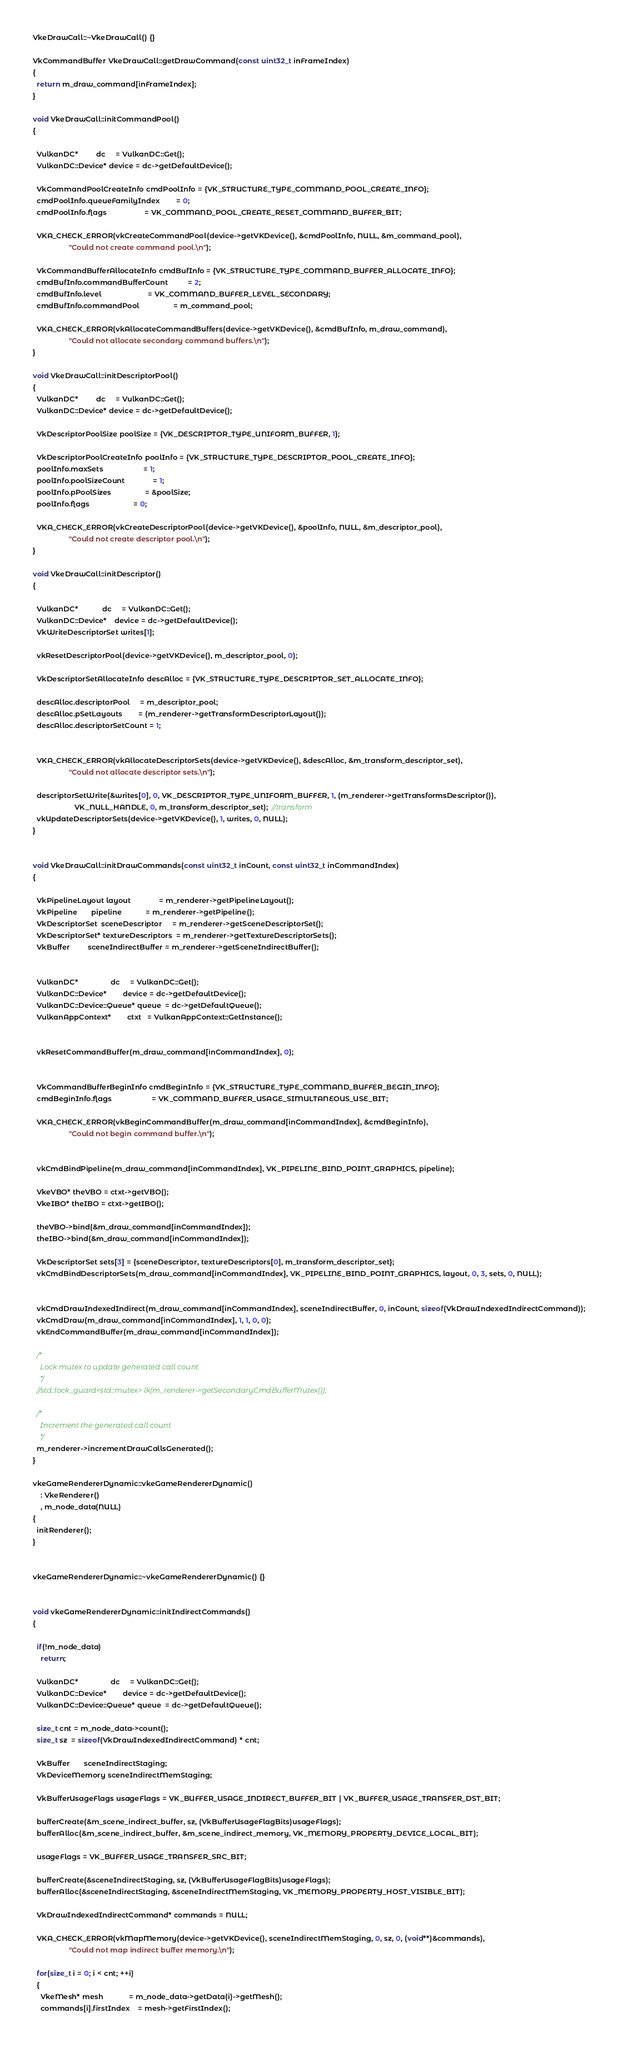Convert code to text. <code><loc_0><loc_0><loc_500><loc_500><_C++_>VkeDrawCall::~VkeDrawCall() {}

VkCommandBuffer VkeDrawCall::getDrawCommand(const uint32_t inFrameIndex)
{
  return m_draw_command[inFrameIndex];
}

void VkeDrawCall::initCommandPool()
{

  VulkanDC*         dc     = VulkanDC::Get();
  VulkanDC::Device* device = dc->getDefaultDevice();

  VkCommandPoolCreateInfo cmdPoolInfo = {VK_STRUCTURE_TYPE_COMMAND_POOL_CREATE_INFO};
  cmdPoolInfo.queueFamilyIndex        = 0;
  cmdPoolInfo.flags                   = VK_COMMAND_POOL_CREATE_RESET_COMMAND_BUFFER_BIT;

  VKA_CHECK_ERROR(vkCreateCommandPool(device->getVKDevice(), &cmdPoolInfo, NULL, &m_command_pool),
                  "Could not create command pool.\n");

  VkCommandBufferAllocateInfo cmdBufInfo = {VK_STRUCTURE_TYPE_COMMAND_BUFFER_ALLOCATE_INFO};
  cmdBufInfo.commandBufferCount          = 2;
  cmdBufInfo.level                       = VK_COMMAND_BUFFER_LEVEL_SECONDARY;
  cmdBufInfo.commandPool                 = m_command_pool;

  VKA_CHECK_ERROR(vkAllocateCommandBuffers(device->getVKDevice(), &cmdBufInfo, m_draw_command),
                  "Could not allocate secondary command buffers.\n");
}

void VkeDrawCall::initDescriptorPool()
{
  VulkanDC*         dc     = VulkanDC::Get();
  VulkanDC::Device* device = dc->getDefaultDevice();

  VkDescriptorPoolSize poolSize = {VK_DESCRIPTOR_TYPE_UNIFORM_BUFFER, 1};

  VkDescriptorPoolCreateInfo poolInfo = {VK_STRUCTURE_TYPE_DESCRIPTOR_POOL_CREATE_INFO};
  poolInfo.maxSets                    = 1;
  poolInfo.poolSizeCount              = 1;
  poolInfo.pPoolSizes                 = &poolSize;
  poolInfo.flags                      = 0;

  VKA_CHECK_ERROR(vkCreateDescriptorPool(device->getVKDevice(), &poolInfo, NULL, &m_descriptor_pool),
                  "Could not create descriptor pool.\n");
}

void VkeDrawCall::initDescriptor()
{

  VulkanDC*            dc     = VulkanDC::Get();
  VulkanDC::Device*    device = dc->getDefaultDevice();
  VkWriteDescriptorSet writes[1];

  vkResetDescriptorPool(device->getVKDevice(), m_descriptor_pool, 0);

  VkDescriptorSetAllocateInfo descAlloc = {VK_STRUCTURE_TYPE_DESCRIPTOR_SET_ALLOCATE_INFO};

  descAlloc.descriptorPool     = m_descriptor_pool;
  descAlloc.pSetLayouts        = (m_renderer->getTransformDescriptorLayout());
  descAlloc.descriptorSetCount = 1;


  VKA_CHECK_ERROR(vkAllocateDescriptorSets(device->getVKDevice(), &descAlloc, &m_transform_descriptor_set),
                  "Could not allocate descriptor sets.\n");

  descriptorSetWrite(&writes[0], 0, VK_DESCRIPTOR_TYPE_UNIFORM_BUFFER, 1, (m_renderer->getTransformsDescriptor()),
                     VK_NULL_HANDLE, 0, m_transform_descriptor_set);  //transform
  vkUpdateDescriptorSets(device->getVKDevice(), 1, writes, 0, NULL);
}


void VkeDrawCall::initDrawCommands(const uint32_t inCount, const uint32_t inCommandIndex)
{

  VkPipelineLayout layout              = m_renderer->getPipelineLayout();
  VkPipeline       pipeline            = m_renderer->getPipeline();
  VkDescriptorSet  sceneDescriptor     = m_renderer->getSceneDescriptorSet();
  VkDescriptorSet* textureDescriptors  = m_renderer->getTextureDescriptorSets();
  VkBuffer         sceneIndirectBuffer = m_renderer->getSceneIndirectBuffer();


  VulkanDC*                dc     = VulkanDC::Get();
  VulkanDC::Device*        device = dc->getDefaultDevice();
  VulkanDC::Device::Queue* queue  = dc->getDefaultQueue();
  VulkanAppContext*        ctxt   = VulkanAppContext::GetInstance();


  vkResetCommandBuffer(m_draw_command[inCommandIndex], 0);


  VkCommandBufferBeginInfo cmdBeginInfo = {VK_STRUCTURE_TYPE_COMMAND_BUFFER_BEGIN_INFO};
  cmdBeginInfo.flags                    = VK_COMMAND_BUFFER_USAGE_SIMULTANEOUS_USE_BIT;

  VKA_CHECK_ERROR(vkBeginCommandBuffer(m_draw_command[inCommandIndex], &cmdBeginInfo),
                  "Could not begin command buffer.\n");


  vkCmdBindPipeline(m_draw_command[inCommandIndex], VK_PIPELINE_BIND_POINT_GRAPHICS, pipeline);

  VkeVBO* theVBO = ctxt->getVBO();
  VkeIBO* theIBO = ctxt->getIBO();

  theVBO->bind(&m_draw_command[inCommandIndex]);
  theIBO->bind(&m_draw_command[inCommandIndex]);

  VkDescriptorSet sets[3] = {sceneDescriptor, textureDescriptors[0], m_transform_descriptor_set};
  vkCmdBindDescriptorSets(m_draw_command[inCommandIndex], VK_PIPELINE_BIND_POINT_GRAPHICS, layout, 0, 3, sets, 0, NULL);


  vkCmdDrawIndexedIndirect(m_draw_command[inCommandIndex], sceneIndirectBuffer, 0, inCount, sizeof(VkDrawIndexedIndirectCommand));
  vkCmdDraw(m_draw_command[inCommandIndex], 1, 1, 0, 0);
  vkEndCommandBuffer(m_draw_command[inCommandIndex]);

  /*
	Lock mutex to update generated call count.
	*/
  //std::lock_guard<std::mutex> lk(m_renderer->getSecondaryCmdBufferMutex());

  /*
	Increment the generated call count
	*/
  m_renderer->incrementDrawCallsGenerated();
}

vkeGameRendererDynamic::vkeGameRendererDynamic()
    : VkeRenderer()
    , m_node_data(NULL)
{
  initRenderer();
}


vkeGameRendererDynamic::~vkeGameRendererDynamic() {}


void vkeGameRendererDynamic::initIndirectCommands()
{

  if(!m_node_data)
    return;

  VulkanDC*                dc     = VulkanDC::Get();
  VulkanDC::Device*        device = dc->getDefaultDevice();
  VulkanDC::Device::Queue* queue  = dc->getDefaultQueue();

  size_t cnt = m_node_data->count();
  size_t sz  = sizeof(VkDrawIndexedIndirectCommand) * cnt;

  VkBuffer       sceneIndirectStaging;
  VkDeviceMemory sceneIndirectMemStaging;

  VkBufferUsageFlags usageFlags = VK_BUFFER_USAGE_INDIRECT_BUFFER_BIT | VK_BUFFER_USAGE_TRANSFER_DST_BIT;

  bufferCreate(&m_scene_indirect_buffer, sz, (VkBufferUsageFlagBits)usageFlags);
  bufferAlloc(&m_scene_indirect_buffer, &m_scene_indirect_memory, VK_MEMORY_PROPERTY_DEVICE_LOCAL_BIT);

  usageFlags = VK_BUFFER_USAGE_TRANSFER_SRC_BIT;

  bufferCreate(&sceneIndirectStaging, sz, (VkBufferUsageFlagBits)usageFlags);
  bufferAlloc(&sceneIndirectStaging, &sceneIndirectMemStaging, VK_MEMORY_PROPERTY_HOST_VISIBLE_BIT);

  VkDrawIndexedIndirectCommand* commands = NULL;

  VKA_CHECK_ERROR(vkMapMemory(device->getVKDevice(), sceneIndirectMemStaging, 0, sz, 0, (void**)&commands),
                  "Could not map indirect buffer memory.\n");

  for(size_t i = 0; i < cnt; ++i)
  {
    VkeMesh* mesh             = m_node_data->getData(i)->getMesh();
    commands[i].firstIndex    = mesh->getFirstIndex();</code> 